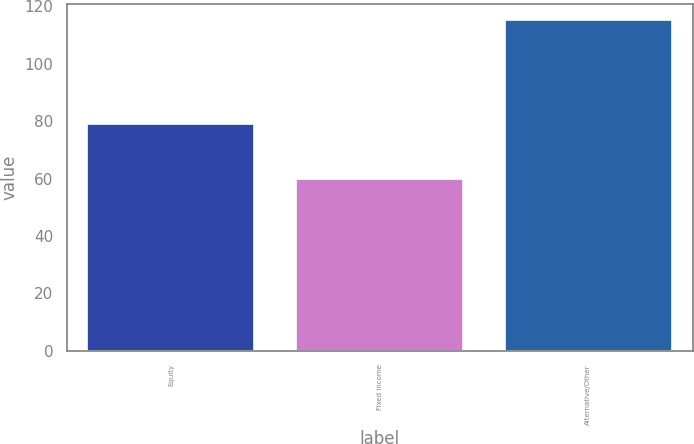Convert chart to OTSL. <chart><loc_0><loc_0><loc_500><loc_500><bar_chart><fcel>Equity<fcel>Fixed income<fcel>Alternative/Other<nl><fcel>79<fcel>60<fcel>115<nl></chart> 